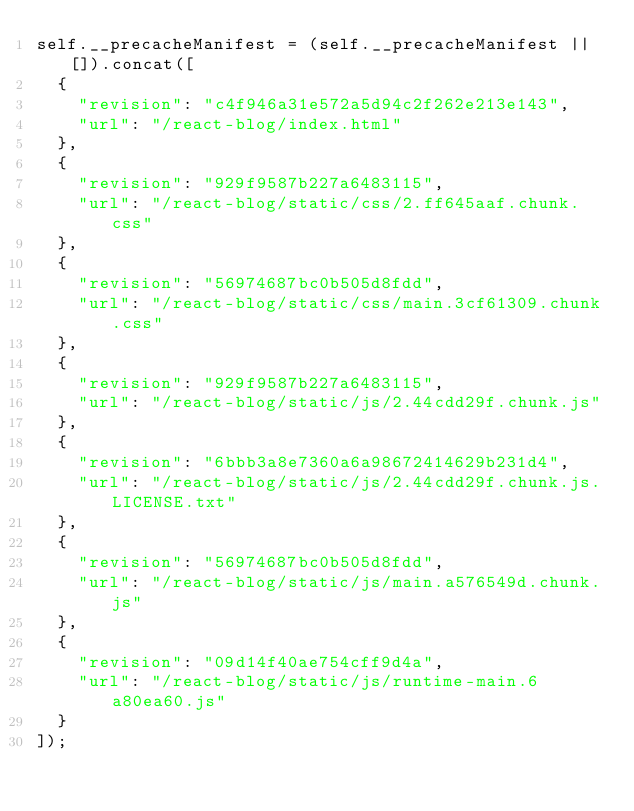Convert code to text. <code><loc_0><loc_0><loc_500><loc_500><_JavaScript_>self.__precacheManifest = (self.__precacheManifest || []).concat([
  {
    "revision": "c4f946a31e572a5d94c2f262e213e143",
    "url": "/react-blog/index.html"
  },
  {
    "revision": "929f9587b227a6483115",
    "url": "/react-blog/static/css/2.ff645aaf.chunk.css"
  },
  {
    "revision": "56974687bc0b505d8fdd",
    "url": "/react-blog/static/css/main.3cf61309.chunk.css"
  },
  {
    "revision": "929f9587b227a6483115",
    "url": "/react-blog/static/js/2.44cdd29f.chunk.js"
  },
  {
    "revision": "6bbb3a8e7360a6a98672414629b231d4",
    "url": "/react-blog/static/js/2.44cdd29f.chunk.js.LICENSE.txt"
  },
  {
    "revision": "56974687bc0b505d8fdd",
    "url": "/react-blog/static/js/main.a576549d.chunk.js"
  },
  {
    "revision": "09d14f40ae754cff9d4a",
    "url": "/react-blog/static/js/runtime-main.6a80ea60.js"
  }
]);</code> 